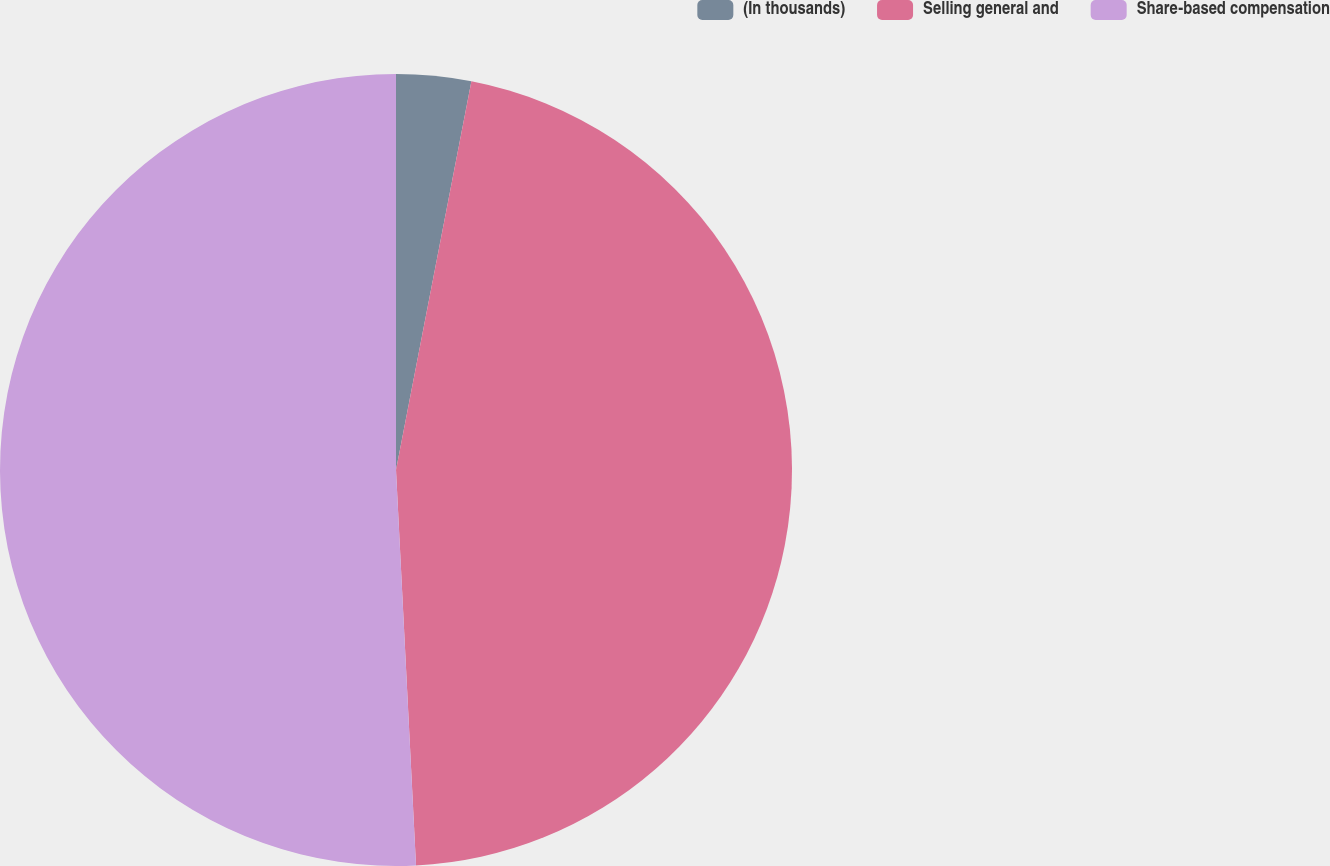Convert chart. <chart><loc_0><loc_0><loc_500><loc_500><pie_chart><fcel>(In thousands)<fcel>Selling general and<fcel>Share-based compensation<nl><fcel>3.05%<fcel>46.15%<fcel>50.81%<nl></chart> 